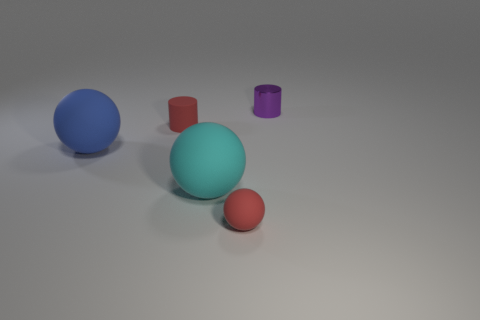Subtract 1 balls. How many balls are left? 2 Add 2 matte things. How many objects exist? 7 Subtract all cylinders. How many objects are left? 3 Subtract 1 red balls. How many objects are left? 4 Subtract all red matte cylinders. Subtract all blue matte things. How many objects are left? 3 Add 5 large matte things. How many large matte things are left? 7 Add 5 purple shiny cylinders. How many purple shiny cylinders exist? 6 